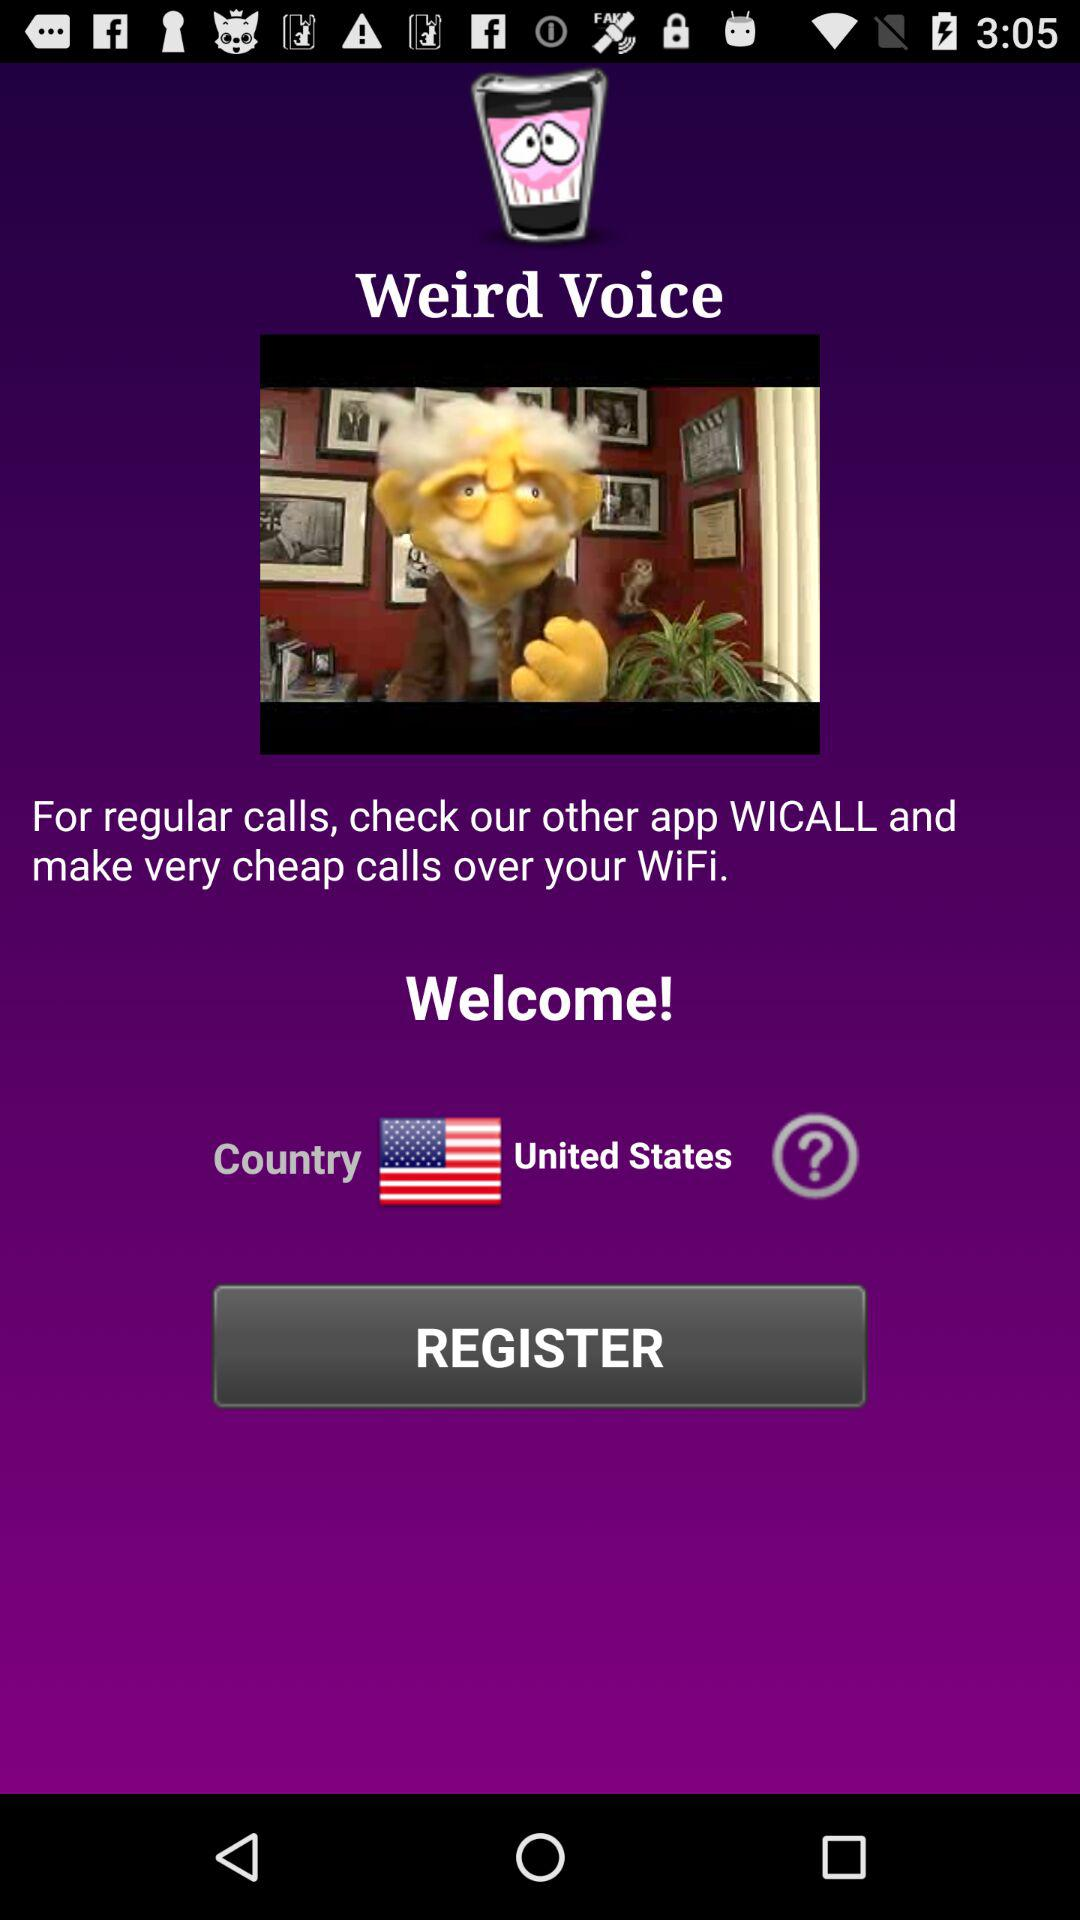Which country has been selected? The selected country is the United States. 